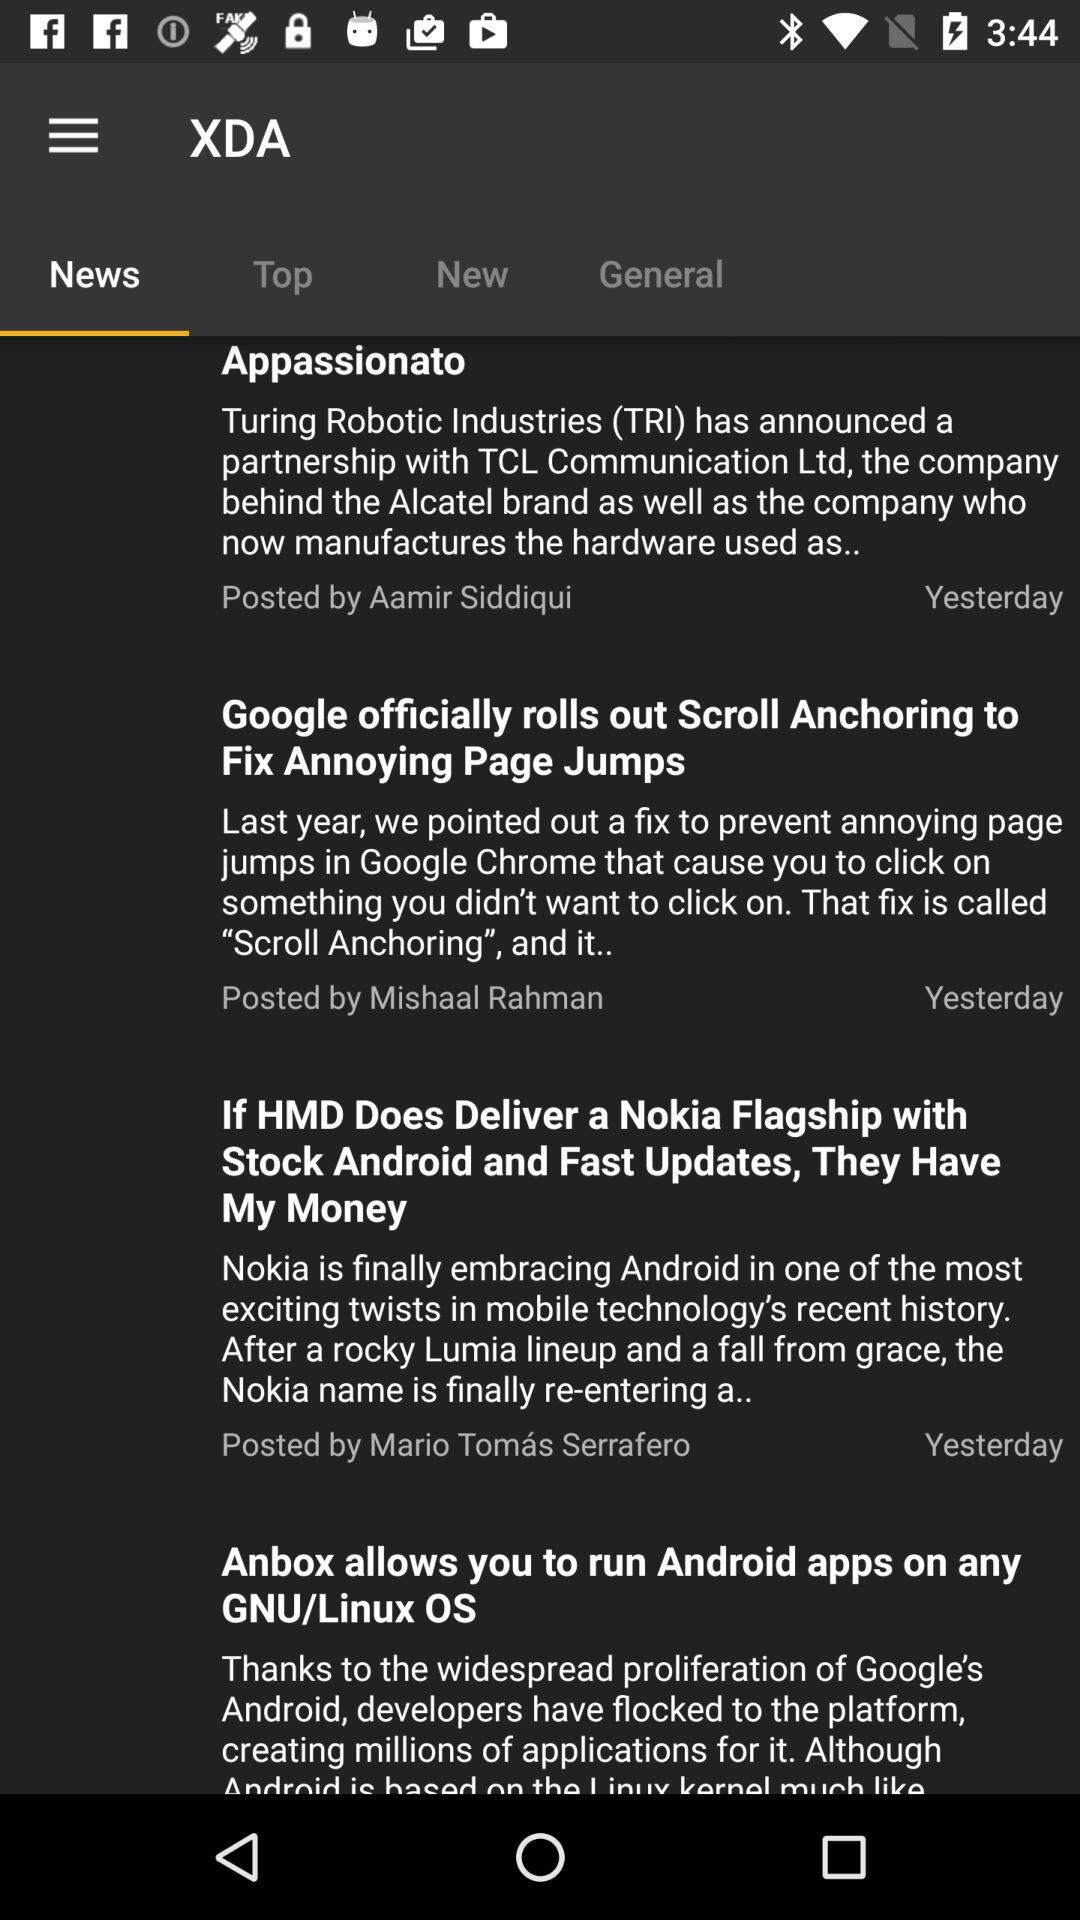How many items are in the news feed?
Answer the question using a single word or phrase. 4 